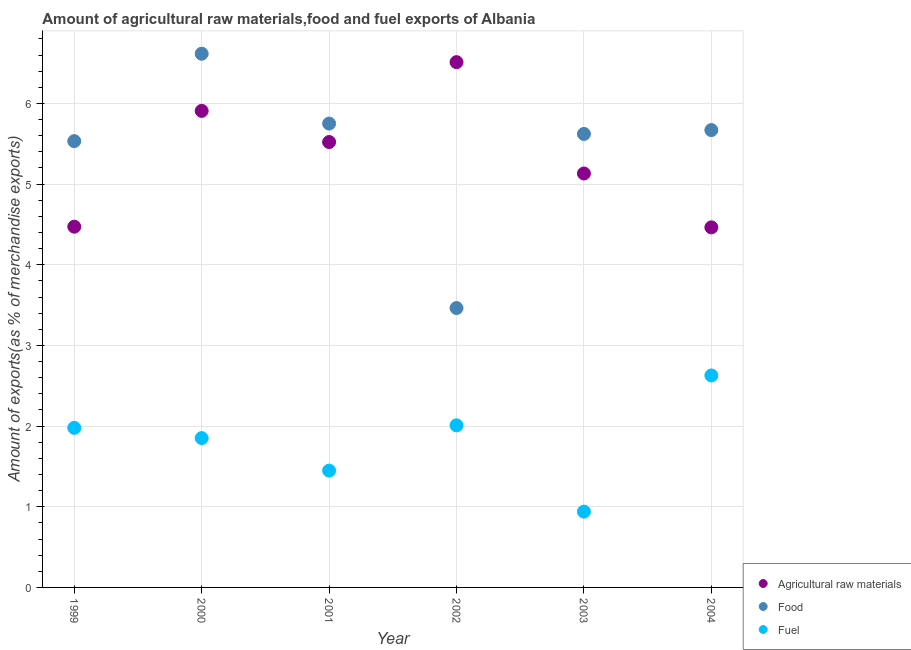Is the number of dotlines equal to the number of legend labels?
Offer a terse response. Yes. What is the percentage of raw materials exports in 2004?
Provide a succinct answer. 4.46. Across all years, what is the maximum percentage of fuel exports?
Provide a short and direct response. 2.63. Across all years, what is the minimum percentage of food exports?
Your answer should be compact. 3.46. What is the total percentage of fuel exports in the graph?
Provide a short and direct response. 10.85. What is the difference between the percentage of fuel exports in 2001 and that in 2004?
Give a very brief answer. -1.18. What is the difference between the percentage of fuel exports in 2001 and the percentage of food exports in 1999?
Your answer should be compact. -4.08. What is the average percentage of fuel exports per year?
Your response must be concise. 1.81. In the year 1999, what is the difference between the percentage of food exports and percentage of raw materials exports?
Your answer should be compact. 1.06. In how many years, is the percentage of food exports greater than 2.6 %?
Keep it short and to the point. 6. What is the ratio of the percentage of raw materials exports in 2001 to that in 2002?
Your response must be concise. 0.85. Is the percentage of food exports in 1999 less than that in 2001?
Provide a succinct answer. Yes. Is the difference between the percentage of raw materials exports in 1999 and 2001 greater than the difference between the percentage of fuel exports in 1999 and 2001?
Ensure brevity in your answer.  No. What is the difference between the highest and the second highest percentage of raw materials exports?
Your answer should be compact. 0.6. What is the difference between the highest and the lowest percentage of raw materials exports?
Your answer should be compact. 2.05. Is the sum of the percentage of fuel exports in 2001 and 2004 greater than the maximum percentage of food exports across all years?
Your answer should be very brief. No. Is it the case that in every year, the sum of the percentage of raw materials exports and percentage of food exports is greater than the percentage of fuel exports?
Offer a very short reply. Yes. How many years are there in the graph?
Make the answer very short. 6. What is the difference between two consecutive major ticks on the Y-axis?
Offer a terse response. 1. Are the values on the major ticks of Y-axis written in scientific E-notation?
Keep it short and to the point. No. Does the graph contain grids?
Offer a terse response. Yes. How many legend labels are there?
Your answer should be compact. 3. What is the title of the graph?
Keep it short and to the point. Amount of agricultural raw materials,food and fuel exports of Albania. What is the label or title of the X-axis?
Offer a terse response. Year. What is the label or title of the Y-axis?
Your answer should be very brief. Amount of exports(as % of merchandise exports). What is the Amount of exports(as % of merchandise exports) of Agricultural raw materials in 1999?
Give a very brief answer. 4.47. What is the Amount of exports(as % of merchandise exports) in Food in 1999?
Ensure brevity in your answer.  5.53. What is the Amount of exports(as % of merchandise exports) of Fuel in 1999?
Offer a terse response. 1.98. What is the Amount of exports(as % of merchandise exports) of Agricultural raw materials in 2000?
Your answer should be very brief. 5.91. What is the Amount of exports(as % of merchandise exports) of Food in 2000?
Make the answer very short. 6.62. What is the Amount of exports(as % of merchandise exports) in Fuel in 2000?
Your answer should be compact. 1.85. What is the Amount of exports(as % of merchandise exports) of Agricultural raw materials in 2001?
Your answer should be compact. 5.52. What is the Amount of exports(as % of merchandise exports) in Food in 2001?
Offer a very short reply. 5.75. What is the Amount of exports(as % of merchandise exports) in Fuel in 2001?
Provide a succinct answer. 1.45. What is the Amount of exports(as % of merchandise exports) of Agricultural raw materials in 2002?
Give a very brief answer. 6.51. What is the Amount of exports(as % of merchandise exports) in Food in 2002?
Offer a terse response. 3.46. What is the Amount of exports(as % of merchandise exports) of Fuel in 2002?
Give a very brief answer. 2.01. What is the Amount of exports(as % of merchandise exports) in Agricultural raw materials in 2003?
Your answer should be compact. 5.13. What is the Amount of exports(as % of merchandise exports) in Food in 2003?
Your answer should be very brief. 5.62. What is the Amount of exports(as % of merchandise exports) in Fuel in 2003?
Ensure brevity in your answer.  0.94. What is the Amount of exports(as % of merchandise exports) of Agricultural raw materials in 2004?
Provide a succinct answer. 4.46. What is the Amount of exports(as % of merchandise exports) of Food in 2004?
Make the answer very short. 5.67. What is the Amount of exports(as % of merchandise exports) in Fuel in 2004?
Provide a short and direct response. 2.63. Across all years, what is the maximum Amount of exports(as % of merchandise exports) of Agricultural raw materials?
Keep it short and to the point. 6.51. Across all years, what is the maximum Amount of exports(as % of merchandise exports) in Food?
Your answer should be very brief. 6.62. Across all years, what is the maximum Amount of exports(as % of merchandise exports) in Fuel?
Provide a short and direct response. 2.63. Across all years, what is the minimum Amount of exports(as % of merchandise exports) in Agricultural raw materials?
Ensure brevity in your answer.  4.46. Across all years, what is the minimum Amount of exports(as % of merchandise exports) in Food?
Offer a very short reply. 3.46. Across all years, what is the minimum Amount of exports(as % of merchandise exports) of Fuel?
Make the answer very short. 0.94. What is the total Amount of exports(as % of merchandise exports) in Agricultural raw materials in the graph?
Provide a succinct answer. 32.01. What is the total Amount of exports(as % of merchandise exports) in Food in the graph?
Offer a very short reply. 32.65. What is the total Amount of exports(as % of merchandise exports) of Fuel in the graph?
Keep it short and to the point. 10.85. What is the difference between the Amount of exports(as % of merchandise exports) of Agricultural raw materials in 1999 and that in 2000?
Keep it short and to the point. -1.44. What is the difference between the Amount of exports(as % of merchandise exports) of Food in 1999 and that in 2000?
Your response must be concise. -1.08. What is the difference between the Amount of exports(as % of merchandise exports) in Fuel in 1999 and that in 2000?
Your answer should be very brief. 0.13. What is the difference between the Amount of exports(as % of merchandise exports) of Agricultural raw materials in 1999 and that in 2001?
Offer a terse response. -1.05. What is the difference between the Amount of exports(as % of merchandise exports) of Food in 1999 and that in 2001?
Your answer should be compact. -0.22. What is the difference between the Amount of exports(as % of merchandise exports) of Fuel in 1999 and that in 2001?
Keep it short and to the point. 0.53. What is the difference between the Amount of exports(as % of merchandise exports) of Agricultural raw materials in 1999 and that in 2002?
Your response must be concise. -2.04. What is the difference between the Amount of exports(as % of merchandise exports) of Food in 1999 and that in 2002?
Your response must be concise. 2.07. What is the difference between the Amount of exports(as % of merchandise exports) of Fuel in 1999 and that in 2002?
Provide a succinct answer. -0.03. What is the difference between the Amount of exports(as % of merchandise exports) in Agricultural raw materials in 1999 and that in 2003?
Offer a terse response. -0.66. What is the difference between the Amount of exports(as % of merchandise exports) in Food in 1999 and that in 2003?
Your response must be concise. -0.09. What is the difference between the Amount of exports(as % of merchandise exports) in Fuel in 1999 and that in 2003?
Ensure brevity in your answer.  1.04. What is the difference between the Amount of exports(as % of merchandise exports) of Agricultural raw materials in 1999 and that in 2004?
Give a very brief answer. 0.01. What is the difference between the Amount of exports(as % of merchandise exports) in Food in 1999 and that in 2004?
Keep it short and to the point. -0.14. What is the difference between the Amount of exports(as % of merchandise exports) of Fuel in 1999 and that in 2004?
Offer a terse response. -0.65. What is the difference between the Amount of exports(as % of merchandise exports) of Agricultural raw materials in 2000 and that in 2001?
Ensure brevity in your answer.  0.39. What is the difference between the Amount of exports(as % of merchandise exports) of Food in 2000 and that in 2001?
Provide a short and direct response. 0.87. What is the difference between the Amount of exports(as % of merchandise exports) of Fuel in 2000 and that in 2001?
Offer a terse response. 0.4. What is the difference between the Amount of exports(as % of merchandise exports) in Agricultural raw materials in 2000 and that in 2002?
Give a very brief answer. -0.6. What is the difference between the Amount of exports(as % of merchandise exports) in Food in 2000 and that in 2002?
Provide a succinct answer. 3.15. What is the difference between the Amount of exports(as % of merchandise exports) of Fuel in 2000 and that in 2002?
Keep it short and to the point. -0.16. What is the difference between the Amount of exports(as % of merchandise exports) in Agricultural raw materials in 2000 and that in 2003?
Make the answer very short. 0.78. What is the difference between the Amount of exports(as % of merchandise exports) in Fuel in 2000 and that in 2003?
Offer a terse response. 0.91. What is the difference between the Amount of exports(as % of merchandise exports) of Agricultural raw materials in 2000 and that in 2004?
Make the answer very short. 1.44. What is the difference between the Amount of exports(as % of merchandise exports) of Food in 2000 and that in 2004?
Offer a very short reply. 0.95. What is the difference between the Amount of exports(as % of merchandise exports) in Fuel in 2000 and that in 2004?
Provide a succinct answer. -0.78. What is the difference between the Amount of exports(as % of merchandise exports) in Agricultural raw materials in 2001 and that in 2002?
Provide a succinct answer. -0.99. What is the difference between the Amount of exports(as % of merchandise exports) in Food in 2001 and that in 2002?
Give a very brief answer. 2.29. What is the difference between the Amount of exports(as % of merchandise exports) in Fuel in 2001 and that in 2002?
Keep it short and to the point. -0.56. What is the difference between the Amount of exports(as % of merchandise exports) in Agricultural raw materials in 2001 and that in 2003?
Your answer should be very brief. 0.39. What is the difference between the Amount of exports(as % of merchandise exports) in Food in 2001 and that in 2003?
Make the answer very short. 0.13. What is the difference between the Amount of exports(as % of merchandise exports) in Fuel in 2001 and that in 2003?
Your response must be concise. 0.51. What is the difference between the Amount of exports(as % of merchandise exports) of Agricultural raw materials in 2001 and that in 2004?
Keep it short and to the point. 1.06. What is the difference between the Amount of exports(as % of merchandise exports) of Food in 2001 and that in 2004?
Your response must be concise. 0.08. What is the difference between the Amount of exports(as % of merchandise exports) in Fuel in 2001 and that in 2004?
Offer a terse response. -1.18. What is the difference between the Amount of exports(as % of merchandise exports) in Agricultural raw materials in 2002 and that in 2003?
Provide a succinct answer. 1.38. What is the difference between the Amount of exports(as % of merchandise exports) of Food in 2002 and that in 2003?
Offer a terse response. -2.16. What is the difference between the Amount of exports(as % of merchandise exports) in Fuel in 2002 and that in 2003?
Offer a terse response. 1.07. What is the difference between the Amount of exports(as % of merchandise exports) in Agricultural raw materials in 2002 and that in 2004?
Make the answer very short. 2.05. What is the difference between the Amount of exports(as % of merchandise exports) in Food in 2002 and that in 2004?
Make the answer very short. -2.21. What is the difference between the Amount of exports(as % of merchandise exports) in Fuel in 2002 and that in 2004?
Provide a short and direct response. -0.62. What is the difference between the Amount of exports(as % of merchandise exports) of Agricultural raw materials in 2003 and that in 2004?
Your response must be concise. 0.67. What is the difference between the Amount of exports(as % of merchandise exports) in Food in 2003 and that in 2004?
Give a very brief answer. -0.05. What is the difference between the Amount of exports(as % of merchandise exports) of Fuel in 2003 and that in 2004?
Give a very brief answer. -1.69. What is the difference between the Amount of exports(as % of merchandise exports) in Agricultural raw materials in 1999 and the Amount of exports(as % of merchandise exports) in Food in 2000?
Make the answer very short. -2.14. What is the difference between the Amount of exports(as % of merchandise exports) in Agricultural raw materials in 1999 and the Amount of exports(as % of merchandise exports) in Fuel in 2000?
Your answer should be very brief. 2.62. What is the difference between the Amount of exports(as % of merchandise exports) of Food in 1999 and the Amount of exports(as % of merchandise exports) of Fuel in 2000?
Give a very brief answer. 3.68. What is the difference between the Amount of exports(as % of merchandise exports) in Agricultural raw materials in 1999 and the Amount of exports(as % of merchandise exports) in Food in 2001?
Your answer should be very brief. -1.28. What is the difference between the Amount of exports(as % of merchandise exports) in Agricultural raw materials in 1999 and the Amount of exports(as % of merchandise exports) in Fuel in 2001?
Provide a succinct answer. 3.02. What is the difference between the Amount of exports(as % of merchandise exports) of Food in 1999 and the Amount of exports(as % of merchandise exports) of Fuel in 2001?
Your response must be concise. 4.08. What is the difference between the Amount of exports(as % of merchandise exports) of Agricultural raw materials in 1999 and the Amount of exports(as % of merchandise exports) of Food in 2002?
Provide a short and direct response. 1.01. What is the difference between the Amount of exports(as % of merchandise exports) in Agricultural raw materials in 1999 and the Amount of exports(as % of merchandise exports) in Fuel in 2002?
Provide a succinct answer. 2.46. What is the difference between the Amount of exports(as % of merchandise exports) of Food in 1999 and the Amount of exports(as % of merchandise exports) of Fuel in 2002?
Provide a succinct answer. 3.52. What is the difference between the Amount of exports(as % of merchandise exports) of Agricultural raw materials in 1999 and the Amount of exports(as % of merchandise exports) of Food in 2003?
Your response must be concise. -1.15. What is the difference between the Amount of exports(as % of merchandise exports) of Agricultural raw materials in 1999 and the Amount of exports(as % of merchandise exports) of Fuel in 2003?
Keep it short and to the point. 3.53. What is the difference between the Amount of exports(as % of merchandise exports) of Food in 1999 and the Amount of exports(as % of merchandise exports) of Fuel in 2003?
Offer a terse response. 4.59. What is the difference between the Amount of exports(as % of merchandise exports) in Agricultural raw materials in 1999 and the Amount of exports(as % of merchandise exports) in Food in 2004?
Offer a terse response. -1.2. What is the difference between the Amount of exports(as % of merchandise exports) of Agricultural raw materials in 1999 and the Amount of exports(as % of merchandise exports) of Fuel in 2004?
Your answer should be very brief. 1.84. What is the difference between the Amount of exports(as % of merchandise exports) in Food in 1999 and the Amount of exports(as % of merchandise exports) in Fuel in 2004?
Provide a succinct answer. 2.9. What is the difference between the Amount of exports(as % of merchandise exports) of Agricultural raw materials in 2000 and the Amount of exports(as % of merchandise exports) of Food in 2001?
Provide a succinct answer. 0.16. What is the difference between the Amount of exports(as % of merchandise exports) of Agricultural raw materials in 2000 and the Amount of exports(as % of merchandise exports) of Fuel in 2001?
Make the answer very short. 4.46. What is the difference between the Amount of exports(as % of merchandise exports) of Food in 2000 and the Amount of exports(as % of merchandise exports) of Fuel in 2001?
Provide a short and direct response. 5.17. What is the difference between the Amount of exports(as % of merchandise exports) in Agricultural raw materials in 2000 and the Amount of exports(as % of merchandise exports) in Food in 2002?
Give a very brief answer. 2.44. What is the difference between the Amount of exports(as % of merchandise exports) in Agricultural raw materials in 2000 and the Amount of exports(as % of merchandise exports) in Fuel in 2002?
Ensure brevity in your answer.  3.9. What is the difference between the Amount of exports(as % of merchandise exports) of Food in 2000 and the Amount of exports(as % of merchandise exports) of Fuel in 2002?
Your answer should be compact. 4.61. What is the difference between the Amount of exports(as % of merchandise exports) of Agricultural raw materials in 2000 and the Amount of exports(as % of merchandise exports) of Food in 2003?
Offer a very short reply. 0.29. What is the difference between the Amount of exports(as % of merchandise exports) of Agricultural raw materials in 2000 and the Amount of exports(as % of merchandise exports) of Fuel in 2003?
Offer a terse response. 4.97. What is the difference between the Amount of exports(as % of merchandise exports) of Food in 2000 and the Amount of exports(as % of merchandise exports) of Fuel in 2003?
Give a very brief answer. 5.68. What is the difference between the Amount of exports(as % of merchandise exports) of Agricultural raw materials in 2000 and the Amount of exports(as % of merchandise exports) of Food in 2004?
Ensure brevity in your answer.  0.24. What is the difference between the Amount of exports(as % of merchandise exports) in Agricultural raw materials in 2000 and the Amount of exports(as % of merchandise exports) in Fuel in 2004?
Offer a terse response. 3.28. What is the difference between the Amount of exports(as % of merchandise exports) in Food in 2000 and the Amount of exports(as % of merchandise exports) in Fuel in 2004?
Give a very brief answer. 3.99. What is the difference between the Amount of exports(as % of merchandise exports) of Agricultural raw materials in 2001 and the Amount of exports(as % of merchandise exports) of Food in 2002?
Provide a succinct answer. 2.06. What is the difference between the Amount of exports(as % of merchandise exports) of Agricultural raw materials in 2001 and the Amount of exports(as % of merchandise exports) of Fuel in 2002?
Provide a short and direct response. 3.51. What is the difference between the Amount of exports(as % of merchandise exports) of Food in 2001 and the Amount of exports(as % of merchandise exports) of Fuel in 2002?
Offer a very short reply. 3.74. What is the difference between the Amount of exports(as % of merchandise exports) of Agricultural raw materials in 2001 and the Amount of exports(as % of merchandise exports) of Food in 2003?
Keep it short and to the point. -0.1. What is the difference between the Amount of exports(as % of merchandise exports) in Agricultural raw materials in 2001 and the Amount of exports(as % of merchandise exports) in Fuel in 2003?
Keep it short and to the point. 4.58. What is the difference between the Amount of exports(as % of merchandise exports) in Food in 2001 and the Amount of exports(as % of merchandise exports) in Fuel in 2003?
Your answer should be very brief. 4.81. What is the difference between the Amount of exports(as % of merchandise exports) of Agricultural raw materials in 2001 and the Amount of exports(as % of merchandise exports) of Food in 2004?
Your answer should be compact. -0.15. What is the difference between the Amount of exports(as % of merchandise exports) of Agricultural raw materials in 2001 and the Amount of exports(as % of merchandise exports) of Fuel in 2004?
Offer a terse response. 2.89. What is the difference between the Amount of exports(as % of merchandise exports) in Food in 2001 and the Amount of exports(as % of merchandise exports) in Fuel in 2004?
Your answer should be very brief. 3.12. What is the difference between the Amount of exports(as % of merchandise exports) in Agricultural raw materials in 2002 and the Amount of exports(as % of merchandise exports) in Food in 2003?
Ensure brevity in your answer.  0.89. What is the difference between the Amount of exports(as % of merchandise exports) of Agricultural raw materials in 2002 and the Amount of exports(as % of merchandise exports) of Fuel in 2003?
Your answer should be very brief. 5.57. What is the difference between the Amount of exports(as % of merchandise exports) of Food in 2002 and the Amount of exports(as % of merchandise exports) of Fuel in 2003?
Offer a terse response. 2.52. What is the difference between the Amount of exports(as % of merchandise exports) in Agricultural raw materials in 2002 and the Amount of exports(as % of merchandise exports) in Food in 2004?
Give a very brief answer. 0.84. What is the difference between the Amount of exports(as % of merchandise exports) in Agricultural raw materials in 2002 and the Amount of exports(as % of merchandise exports) in Fuel in 2004?
Your answer should be very brief. 3.88. What is the difference between the Amount of exports(as % of merchandise exports) of Food in 2002 and the Amount of exports(as % of merchandise exports) of Fuel in 2004?
Provide a succinct answer. 0.84. What is the difference between the Amount of exports(as % of merchandise exports) in Agricultural raw materials in 2003 and the Amount of exports(as % of merchandise exports) in Food in 2004?
Your answer should be compact. -0.54. What is the difference between the Amount of exports(as % of merchandise exports) of Agricultural raw materials in 2003 and the Amount of exports(as % of merchandise exports) of Fuel in 2004?
Make the answer very short. 2.5. What is the difference between the Amount of exports(as % of merchandise exports) in Food in 2003 and the Amount of exports(as % of merchandise exports) in Fuel in 2004?
Your answer should be compact. 2.99. What is the average Amount of exports(as % of merchandise exports) of Agricultural raw materials per year?
Offer a very short reply. 5.33. What is the average Amount of exports(as % of merchandise exports) of Food per year?
Your answer should be very brief. 5.44. What is the average Amount of exports(as % of merchandise exports) in Fuel per year?
Your answer should be very brief. 1.81. In the year 1999, what is the difference between the Amount of exports(as % of merchandise exports) of Agricultural raw materials and Amount of exports(as % of merchandise exports) of Food?
Offer a very short reply. -1.06. In the year 1999, what is the difference between the Amount of exports(as % of merchandise exports) in Agricultural raw materials and Amount of exports(as % of merchandise exports) in Fuel?
Make the answer very short. 2.49. In the year 1999, what is the difference between the Amount of exports(as % of merchandise exports) of Food and Amount of exports(as % of merchandise exports) of Fuel?
Give a very brief answer. 3.55. In the year 2000, what is the difference between the Amount of exports(as % of merchandise exports) of Agricultural raw materials and Amount of exports(as % of merchandise exports) of Food?
Your answer should be compact. -0.71. In the year 2000, what is the difference between the Amount of exports(as % of merchandise exports) of Agricultural raw materials and Amount of exports(as % of merchandise exports) of Fuel?
Keep it short and to the point. 4.06. In the year 2000, what is the difference between the Amount of exports(as % of merchandise exports) of Food and Amount of exports(as % of merchandise exports) of Fuel?
Keep it short and to the point. 4.76. In the year 2001, what is the difference between the Amount of exports(as % of merchandise exports) of Agricultural raw materials and Amount of exports(as % of merchandise exports) of Food?
Your answer should be very brief. -0.23. In the year 2001, what is the difference between the Amount of exports(as % of merchandise exports) of Agricultural raw materials and Amount of exports(as % of merchandise exports) of Fuel?
Your answer should be compact. 4.07. In the year 2001, what is the difference between the Amount of exports(as % of merchandise exports) in Food and Amount of exports(as % of merchandise exports) in Fuel?
Make the answer very short. 4.3. In the year 2002, what is the difference between the Amount of exports(as % of merchandise exports) in Agricultural raw materials and Amount of exports(as % of merchandise exports) in Food?
Keep it short and to the point. 3.05. In the year 2002, what is the difference between the Amount of exports(as % of merchandise exports) in Agricultural raw materials and Amount of exports(as % of merchandise exports) in Fuel?
Provide a succinct answer. 4.5. In the year 2002, what is the difference between the Amount of exports(as % of merchandise exports) of Food and Amount of exports(as % of merchandise exports) of Fuel?
Provide a short and direct response. 1.45. In the year 2003, what is the difference between the Amount of exports(as % of merchandise exports) in Agricultural raw materials and Amount of exports(as % of merchandise exports) in Food?
Offer a very short reply. -0.49. In the year 2003, what is the difference between the Amount of exports(as % of merchandise exports) in Agricultural raw materials and Amount of exports(as % of merchandise exports) in Fuel?
Keep it short and to the point. 4.19. In the year 2003, what is the difference between the Amount of exports(as % of merchandise exports) of Food and Amount of exports(as % of merchandise exports) of Fuel?
Give a very brief answer. 4.68. In the year 2004, what is the difference between the Amount of exports(as % of merchandise exports) in Agricultural raw materials and Amount of exports(as % of merchandise exports) in Food?
Make the answer very short. -1.21. In the year 2004, what is the difference between the Amount of exports(as % of merchandise exports) of Agricultural raw materials and Amount of exports(as % of merchandise exports) of Fuel?
Ensure brevity in your answer.  1.84. In the year 2004, what is the difference between the Amount of exports(as % of merchandise exports) in Food and Amount of exports(as % of merchandise exports) in Fuel?
Keep it short and to the point. 3.04. What is the ratio of the Amount of exports(as % of merchandise exports) in Agricultural raw materials in 1999 to that in 2000?
Give a very brief answer. 0.76. What is the ratio of the Amount of exports(as % of merchandise exports) of Food in 1999 to that in 2000?
Your answer should be very brief. 0.84. What is the ratio of the Amount of exports(as % of merchandise exports) in Fuel in 1999 to that in 2000?
Give a very brief answer. 1.07. What is the ratio of the Amount of exports(as % of merchandise exports) in Agricultural raw materials in 1999 to that in 2001?
Your answer should be compact. 0.81. What is the ratio of the Amount of exports(as % of merchandise exports) in Food in 1999 to that in 2001?
Provide a succinct answer. 0.96. What is the ratio of the Amount of exports(as % of merchandise exports) in Fuel in 1999 to that in 2001?
Provide a short and direct response. 1.37. What is the ratio of the Amount of exports(as % of merchandise exports) in Agricultural raw materials in 1999 to that in 2002?
Your answer should be very brief. 0.69. What is the ratio of the Amount of exports(as % of merchandise exports) of Food in 1999 to that in 2002?
Make the answer very short. 1.6. What is the ratio of the Amount of exports(as % of merchandise exports) in Fuel in 1999 to that in 2002?
Provide a succinct answer. 0.98. What is the ratio of the Amount of exports(as % of merchandise exports) of Agricultural raw materials in 1999 to that in 2003?
Offer a very short reply. 0.87. What is the ratio of the Amount of exports(as % of merchandise exports) in Food in 1999 to that in 2003?
Offer a very short reply. 0.98. What is the ratio of the Amount of exports(as % of merchandise exports) of Fuel in 1999 to that in 2003?
Your response must be concise. 2.11. What is the ratio of the Amount of exports(as % of merchandise exports) of Food in 1999 to that in 2004?
Offer a very short reply. 0.98. What is the ratio of the Amount of exports(as % of merchandise exports) in Fuel in 1999 to that in 2004?
Your answer should be very brief. 0.75. What is the ratio of the Amount of exports(as % of merchandise exports) in Agricultural raw materials in 2000 to that in 2001?
Give a very brief answer. 1.07. What is the ratio of the Amount of exports(as % of merchandise exports) in Food in 2000 to that in 2001?
Give a very brief answer. 1.15. What is the ratio of the Amount of exports(as % of merchandise exports) of Fuel in 2000 to that in 2001?
Make the answer very short. 1.28. What is the ratio of the Amount of exports(as % of merchandise exports) in Agricultural raw materials in 2000 to that in 2002?
Offer a very short reply. 0.91. What is the ratio of the Amount of exports(as % of merchandise exports) of Food in 2000 to that in 2002?
Your answer should be compact. 1.91. What is the ratio of the Amount of exports(as % of merchandise exports) in Fuel in 2000 to that in 2002?
Your response must be concise. 0.92. What is the ratio of the Amount of exports(as % of merchandise exports) in Agricultural raw materials in 2000 to that in 2003?
Provide a succinct answer. 1.15. What is the ratio of the Amount of exports(as % of merchandise exports) of Food in 2000 to that in 2003?
Make the answer very short. 1.18. What is the ratio of the Amount of exports(as % of merchandise exports) in Fuel in 2000 to that in 2003?
Give a very brief answer. 1.97. What is the ratio of the Amount of exports(as % of merchandise exports) in Agricultural raw materials in 2000 to that in 2004?
Ensure brevity in your answer.  1.32. What is the ratio of the Amount of exports(as % of merchandise exports) in Food in 2000 to that in 2004?
Your response must be concise. 1.17. What is the ratio of the Amount of exports(as % of merchandise exports) of Fuel in 2000 to that in 2004?
Your response must be concise. 0.7. What is the ratio of the Amount of exports(as % of merchandise exports) in Agricultural raw materials in 2001 to that in 2002?
Ensure brevity in your answer.  0.85. What is the ratio of the Amount of exports(as % of merchandise exports) of Food in 2001 to that in 2002?
Make the answer very short. 1.66. What is the ratio of the Amount of exports(as % of merchandise exports) in Fuel in 2001 to that in 2002?
Give a very brief answer. 0.72. What is the ratio of the Amount of exports(as % of merchandise exports) of Agricultural raw materials in 2001 to that in 2003?
Give a very brief answer. 1.08. What is the ratio of the Amount of exports(as % of merchandise exports) of Food in 2001 to that in 2003?
Provide a succinct answer. 1.02. What is the ratio of the Amount of exports(as % of merchandise exports) of Fuel in 2001 to that in 2003?
Provide a succinct answer. 1.54. What is the ratio of the Amount of exports(as % of merchandise exports) in Agricultural raw materials in 2001 to that in 2004?
Make the answer very short. 1.24. What is the ratio of the Amount of exports(as % of merchandise exports) in Food in 2001 to that in 2004?
Provide a succinct answer. 1.01. What is the ratio of the Amount of exports(as % of merchandise exports) in Fuel in 2001 to that in 2004?
Ensure brevity in your answer.  0.55. What is the ratio of the Amount of exports(as % of merchandise exports) of Agricultural raw materials in 2002 to that in 2003?
Your answer should be compact. 1.27. What is the ratio of the Amount of exports(as % of merchandise exports) of Food in 2002 to that in 2003?
Your response must be concise. 0.62. What is the ratio of the Amount of exports(as % of merchandise exports) in Fuel in 2002 to that in 2003?
Your answer should be very brief. 2.14. What is the ratio of the Amount of exports(as % of merchandise exports) of Agricultural raw materials in 2002 to that in 2004?
Give a very brief answer. 1.46. What is the ratio of the Amount of exports(as % of merchandise exports) of Food in 2002 to that in 2004?
Keep it short and to the point. 0.61. What is the ratio of the Amount of exports(as % of merchandise exports) in Fuel in 2002 to that in 2004?
Keep it short and to the point. 0.76. What is the ratio of the Amount of exports(as % of merchandise exports) of Agricultural raw materials in 2003 to that in 2004?
Provide a short and direct response. 1.15. What is the ratio of the Amount of exports(as % of merchandise exports) of Fuel in 2003 to that in 2004?
Keep it short and to the point. 0.36. What is the difference between the highest and the second highest Amount of exports(as % of merchandise exports) in Agricultural raw materials?
Offer a terse response. 0.6. What is the difference between the highest and the second highest Amount of exports(as % of merchandise exports) of Food?
Keep it short and to the point. 0.87. What is the difference between the highest and the second highest Amount of exports(as % of merchandise exports) in Fuel?
Ensure brevity in your answer.  0.62. What is the difference between the highest and the lowest Amount of exports(as % of merchandise exports) in Agricultural raw materials?
Give a very brief answer. 2.05. What is the difference between the highest and the lowest Amount of exports(as % of merchandise exports) of Food?
Provide a succinct answer. 3.15. What is the difference between the highest and the lowest Amount of exports(as % of merchandise exports) of Fuel?
Offer a very short reply. 1.69. 